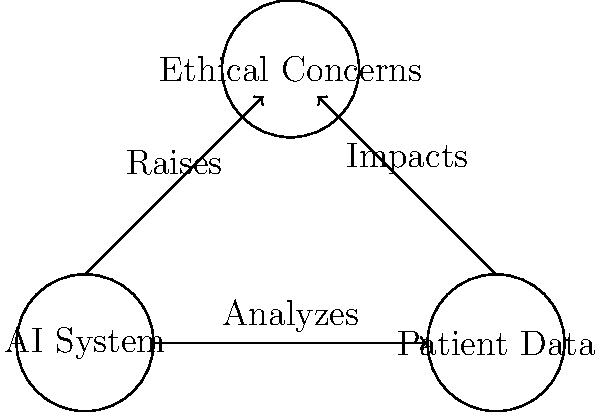In the context of AI systems in healthcare, as depicted in the network graph, what is the primary ethical concern that arises from the interaction between AI systems and patient data, and how might this impact the development of healthcare policies? To answer this question, let's analyze the network graph and consider the ethical implications step-by-step:

1. AI System and Patient Data Interaction:
   The graph shows an arrow from the AI System to Patient Data labeled "Analyzes." This indicates that AI systems are processing and interpreting patient information.

2. Ethical Concerns:
   Both the AI System and Patient Data nodes have arrows pointing to the Ethical Concerns node, suggesting that the interaction between these two elements raises ethical issues.

3. Primary Ethical Concern:
   The main ethical concern in this context is likely to be patient privacy and data protection. AI systems require large amounts of data to function effectively, but this data contains sensitive personal health information.

4. Implications for Policy Development:
   a) Data Governance: Policies need to be developed to ensure proper collection, storage, and use of patient data by AI systems.
   b) Informed Consent: Guidelines for obtaining patient consent for AI analysis of their data must be established.
   c) Algorithmic Transparency: Policies should address the need for explainable AI in healthcare to ensure accountability.
   d) Data Sharing: Regulations on how and when patient data can be shared for AI development and research purposes.
   e) Equity and Fairness: Policies must ensure that AI systems do not perpetuate or exacerbate existing healthcare disparities.

5. Balancing Innovation and Ethics:
   The challenge for policymakers is to create a regulatory framework that protects patient rights and privacy while still allowing for innovation in AI-driven healthcare solutions.

6. Continuous Evaluation:
   As AI technology evolves, policies will need to be regularly reviewed and updated to address new ethical challenges that may arise.
Answer: Patient privacy and data protection, balanced with innovation in AI-driven healthcare. 